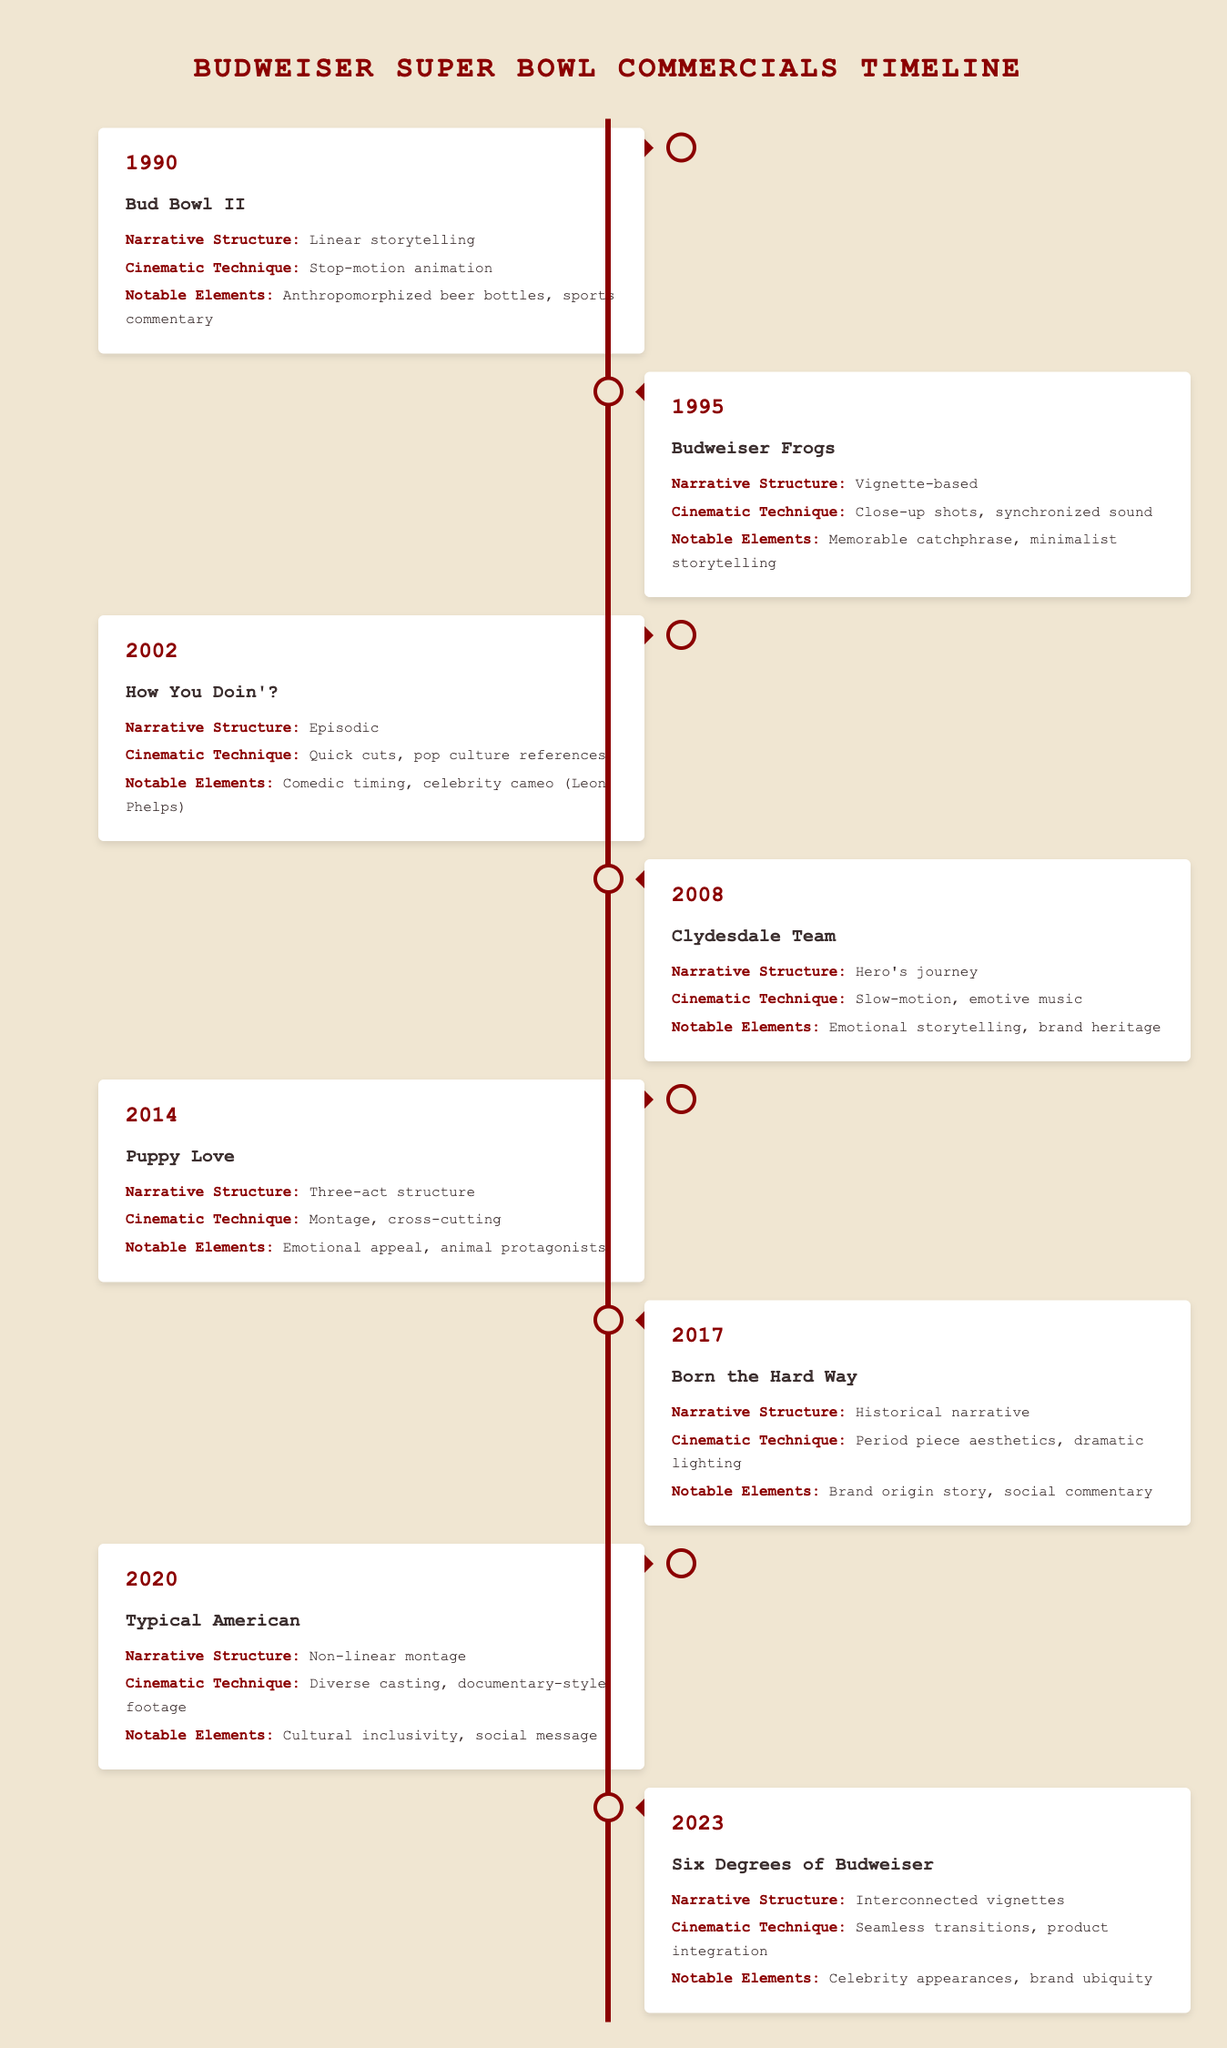What is the narrative structure of the 2020 Budweiser commercial? The table indicates that the narrative structure of the 2020 commercial titled "Typical American" is "Non-linear montage."
Answer: Non-linear montage Which cinematic technique was used in "Puppy Love"? According to the table, the cinematic technique used in the 2014 commercial "Puppy Love" is "Montage, cross-cutting."
Answer: Montage, cross-cutting How many commercials are based on a hero's journey narrative structure? The table shows that only one commercial, "Clydesdale Team" from 2008, follows the hero's journey narrative structure.
Answer: 1 Was the "Budweiser Frogs" commercial released after 1995? The table lists "Budweiser Frogs" as being released in 1995, so it was not released after that year.
Answer: No Which two commercials feature animal protagonists? The table shows that "Puppy Love" (2014) and "Clydesdale Team" (2008) feature animal protagonists.
Answer: Puppy Love, Clydesdale Team In what year did Budweiser start using non-linear narrative structures in their commercials? The first commercial that utilized a non-linear narrative structure is "Typical American," released in 2020, indicating that is the year Budweiser started using this storytelling technique.
Answer: 2020 How does the narrative structure of "Born the Hard Way" differ from that of "How You Doin'?" "Born the Hard Way" follows a "Historical narrative," while "How You Doin'?" follows an "Episodic" structure. This showcases a shift from storytelling focused on specific moments to a broader historical context.
Answer: Different narrative structures What is the notable element of the 2023 commercial "Six Degrees of Budweiser"? The table classifies a key notable element of "Six Degrees of Budweiser" (2023) as "Celebrity appearances, brand ubiquity."
Answer: Celebrity appearances, brand ubiquity 